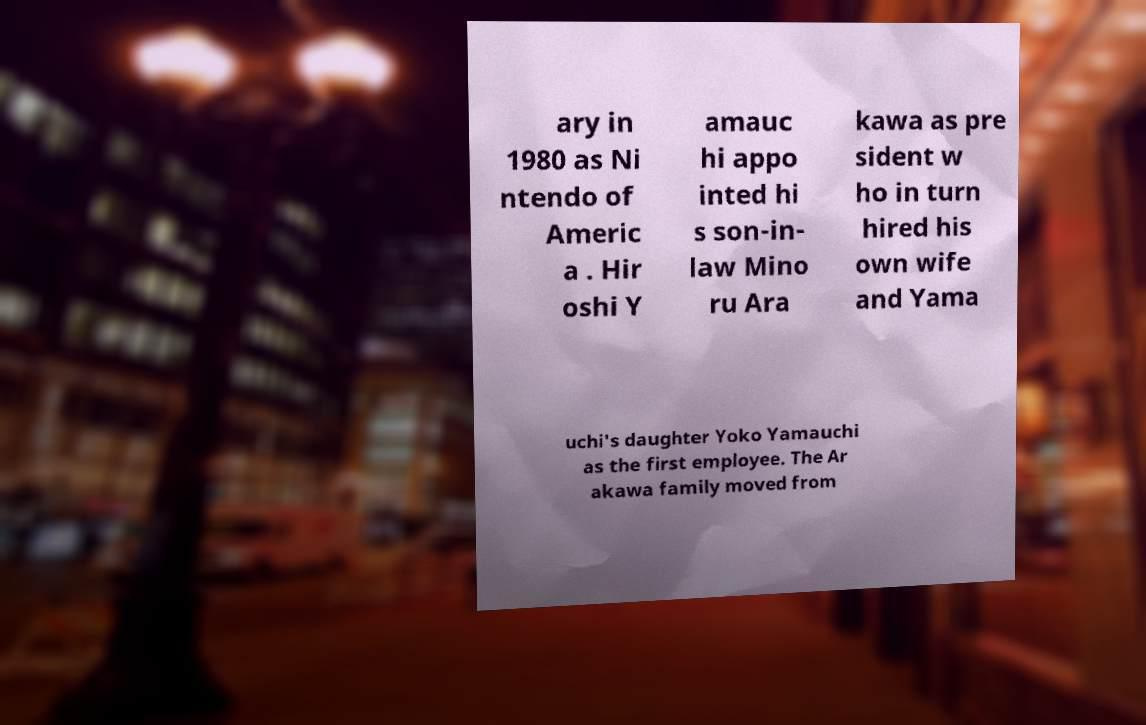Can you accurately transcribe the text from the provided image for me? ary in 1980 as Ni ntendo of Americ a . Hir oshi Y amauc hi appo inted hi s son-in- law Mino ru Ara kawa as pre sident w ho in turn hired his own wife and Yama uchi's daughter Yoko Yamauchi as the first employee. The Ar akawa family moved from 